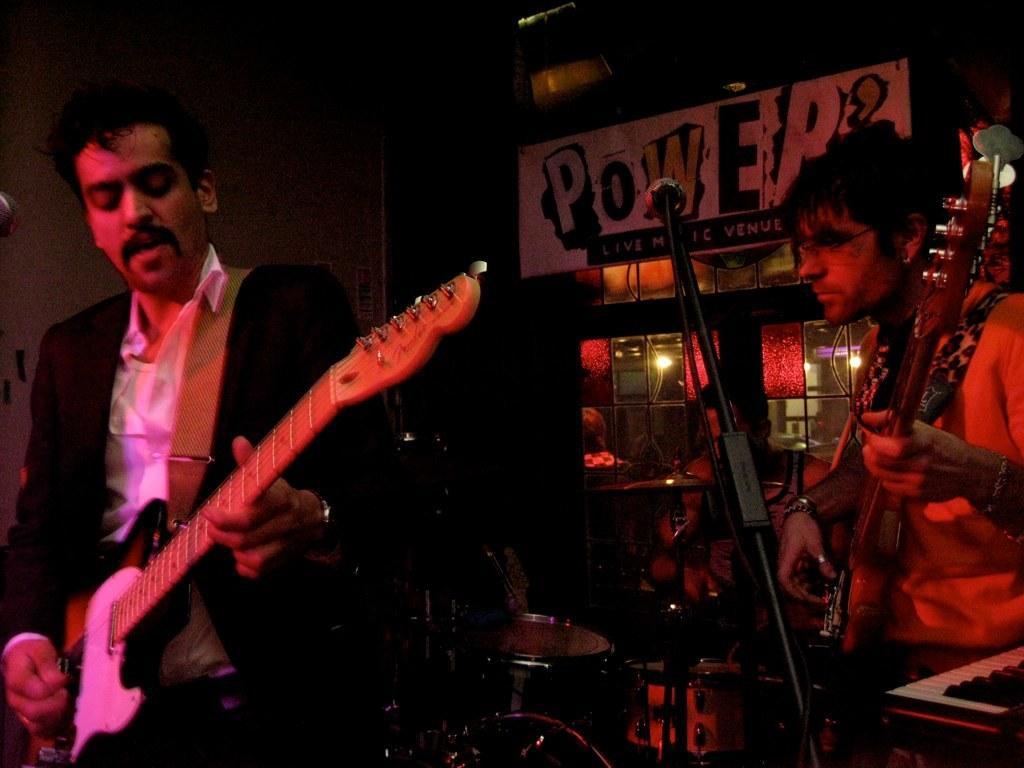Could you give a brief overview of what you see in this image? This image might be clicked in a musical concert. There are three persons who are playing musical instruments, two of them are playing guitar and the one who is on the back side is playing drums. There is "POWER" written on the top. 